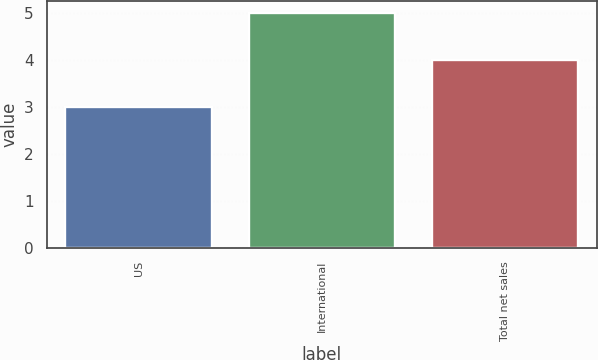Convert chart to OTSL. <chart><loc_0><loc_0><loc_500><loc_500><bar_chart><fcel>US<fcel>International<fcel>Total net sales<nl><fcel>3<fcel>5<fcel>4<nl></chart> 